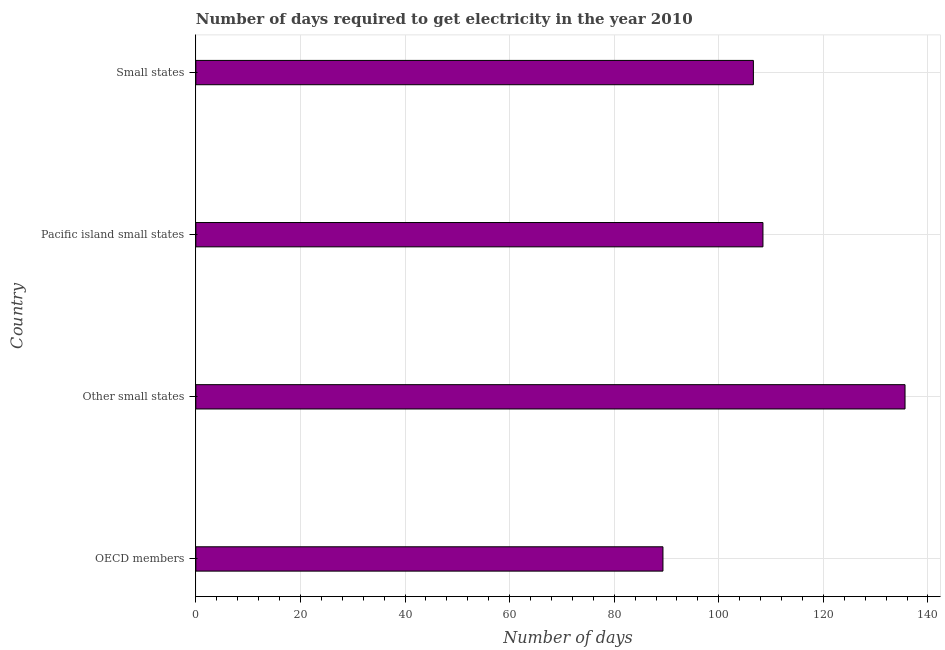What is the title of the graph?
Ensure brevity in your answer.  Number of days required to get electricity in the year 2010. What is the label or title of the X-axis?
Make the answer very short. Number of days. What is the time to get electricity in OECD members?
Provide a short and direct response. 89.32. Across all countries, what is the maximum time to get electricity?
Keep it short and to the point. 135.61. Across all countries, what is the minimum time to get electricity?
Ensure brevity in your answer.  89.32. In which country was the time to get electricity maximum?
Your answer should be very brief. Other small states. In which country was the time to get electricity minimum?
Make the answer very short. OECD members. What is the sum of the time to get electricity?
Your response must be concise. 439.99. What is the difference between the time to get electricity in Other small states and Pacific island small states?
Keep it short and to the point. 27.17. What is the average time to get electricity per country?
Offer a very short reply. 110. What is the median time to get electricity?
Offer a terse response. 107.53. In how many countries, is the time to get electricity greater than 132 ?
Provide a succinct answer. 1. What is the difference between the highest and the second highest time to get electricity?
Provide a short and direct response. 27.17. Is the sum of the time to get electricity in Other small states and Pacific island small states greater than the maximum time to get electricity across all countries?
Provide a succinct answer. Yes. What is the difference between the highest and the lowest time to get electricity?
Your answer should be very brief. 46.29. How many countries are there in the graph?
Your answer should be compact. 4. What is the difference between two consecutive major ticks on the X-axis?
Make the answer very short. 20. Are the values on the major ticks of X-axis written in scientific E-notation?
Offer a terse response. No. What is the Number of days of OECD members?
Make the answer very short. 89.32. What is the Number of days in Other small states?
Your response must be concise. 135.61. What is the Number of days in Pacific island small states?
Make the answer very short. 108.44. What is the Number of days in Small states?
Keep it short and to the point. 106.62. What is the difference between the Number of days in OECD members and Other small states?
Ensure brevity in your answer.  -46.29. What is the difference between the Number of days in OECD members and Pacific island small states?
Your answer should be compact. -19.12. What is the difference between the Number of days in OECD members and Small states?
Ensure brevity in your answer.  -17.29. What is the difference between the Number of days in Other small states and Pacific island small states?
Ensure brevity in your answer.  27.17. What is the difference between the Number of days in Other small states and Small states?
Make the answer very short. 29. What is the difference between the Number of days in Pacific island small states and Small states?
Your answer should be very brief. 1.83. What is the ratio of the Number of days in OECD members to that in Other small states?
Keep it short and to the point. 0.66. What is the ratio of the Number of days in OECD members to that in Pacific island small states?
Offer a very short reply. 0.82. What is the ratio of the Number of days in OECD members to that in Small states?
Provide a succinct answer. 0.84. What is the ratio of the Number of days in Other small states to that in Pacific island small states?
Offer a terse response. 1.25. What is the ratio of the Number of days in Other small states to that in Small states?
Give a very brief answer. 1.27. What is the ratio of the Number of days in Pacific island small states to that in Small states?
Your answer should be compact. 1.02. 